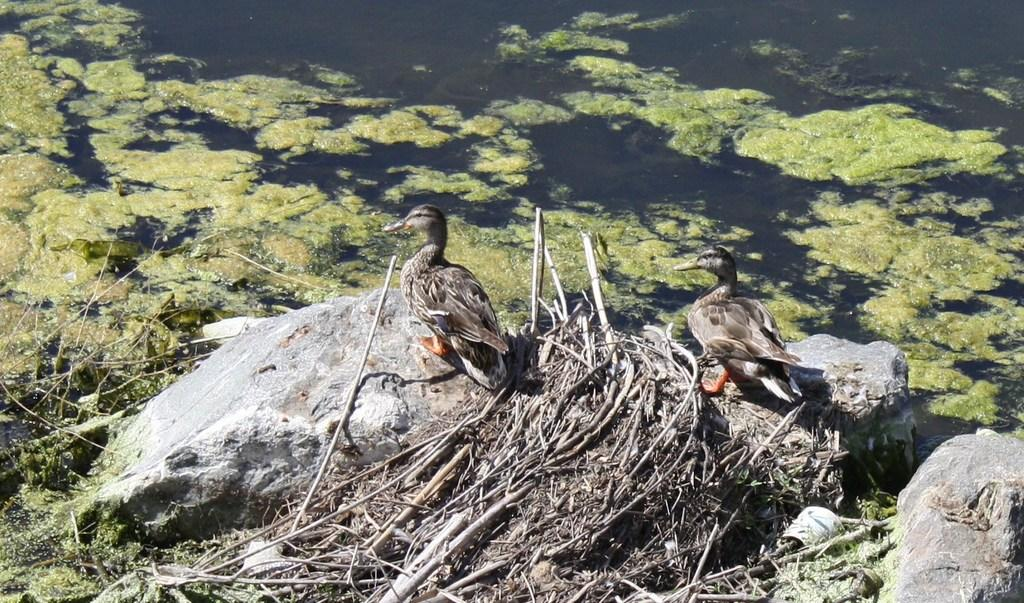How many birds can be seen in the image? There are two birds in the image. What colors are the birds? The birds are in brown and gray colors. Where are the birds standing? The birds are standing on a rock. What can be seen in the background of the image? There is water visible in the background of the image. Can you see a nest in the image? There is no nest visible in the image. What type of clam is present in the image? There are no clams present in the image; it features two birds standing on a rock with water visible in the background. 